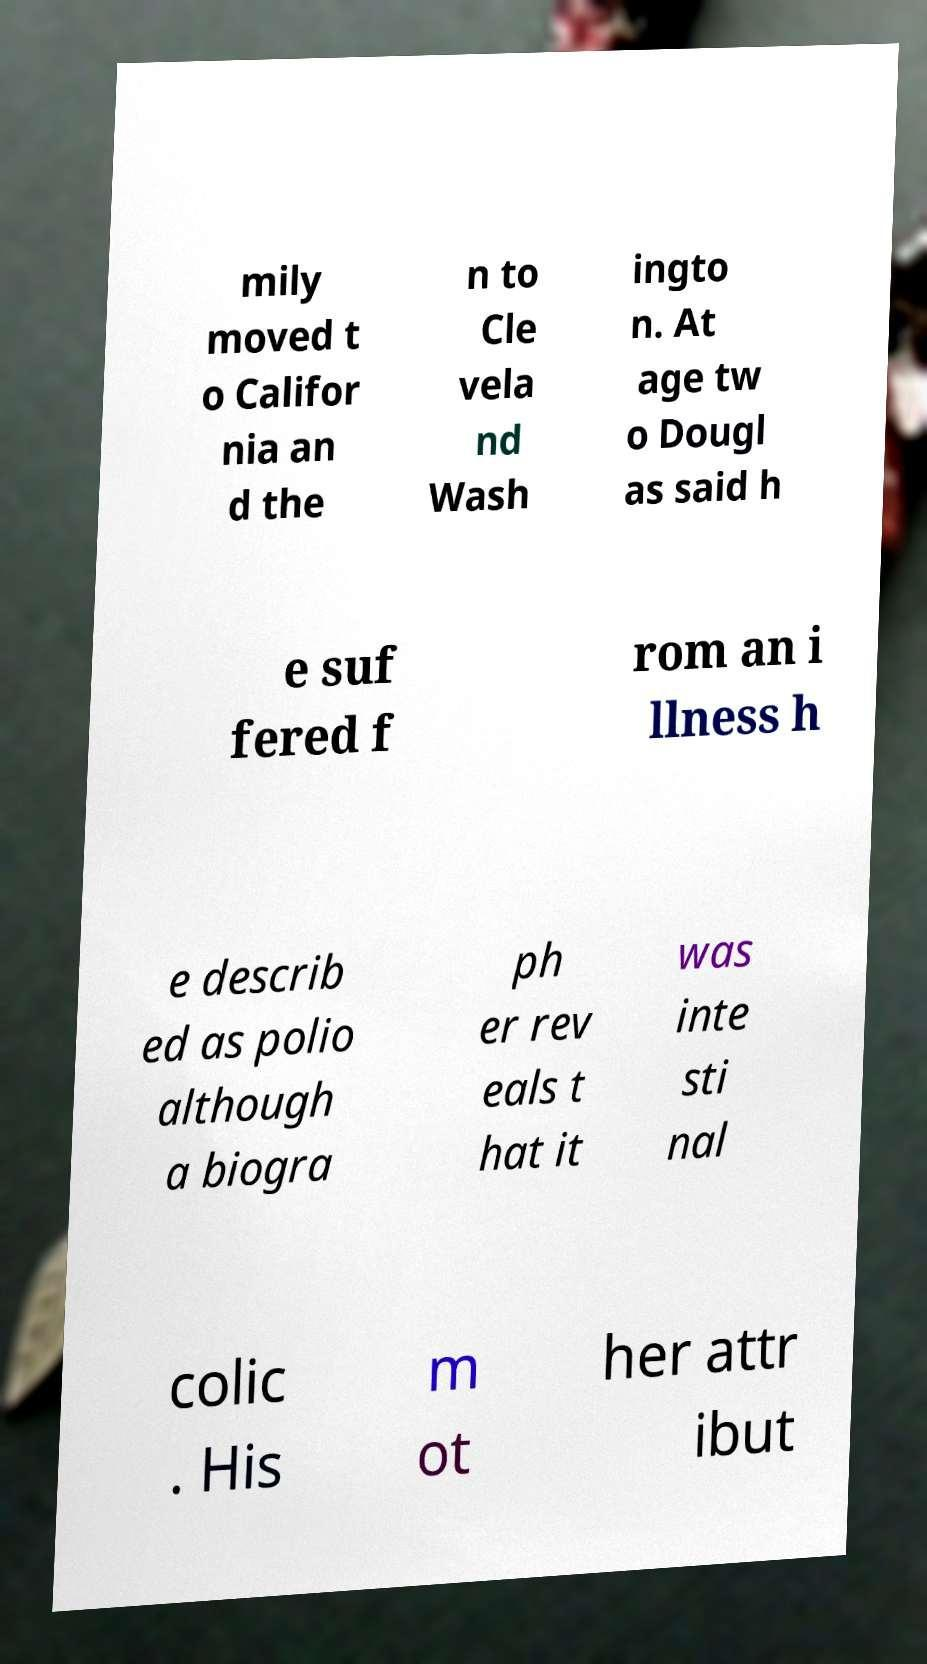For documentation purposes, I need the text within this image transcribed. Could you provide that? mily moved t o Califor nia an d the n to Cle vela nd Wash ingto n. At age tw o Dougl as said h e suf fered f rom an i llness h e describ ed as polio although a biogra ph er rev eals t hat it was inte sti nal colic . His m ot her attr ibut 